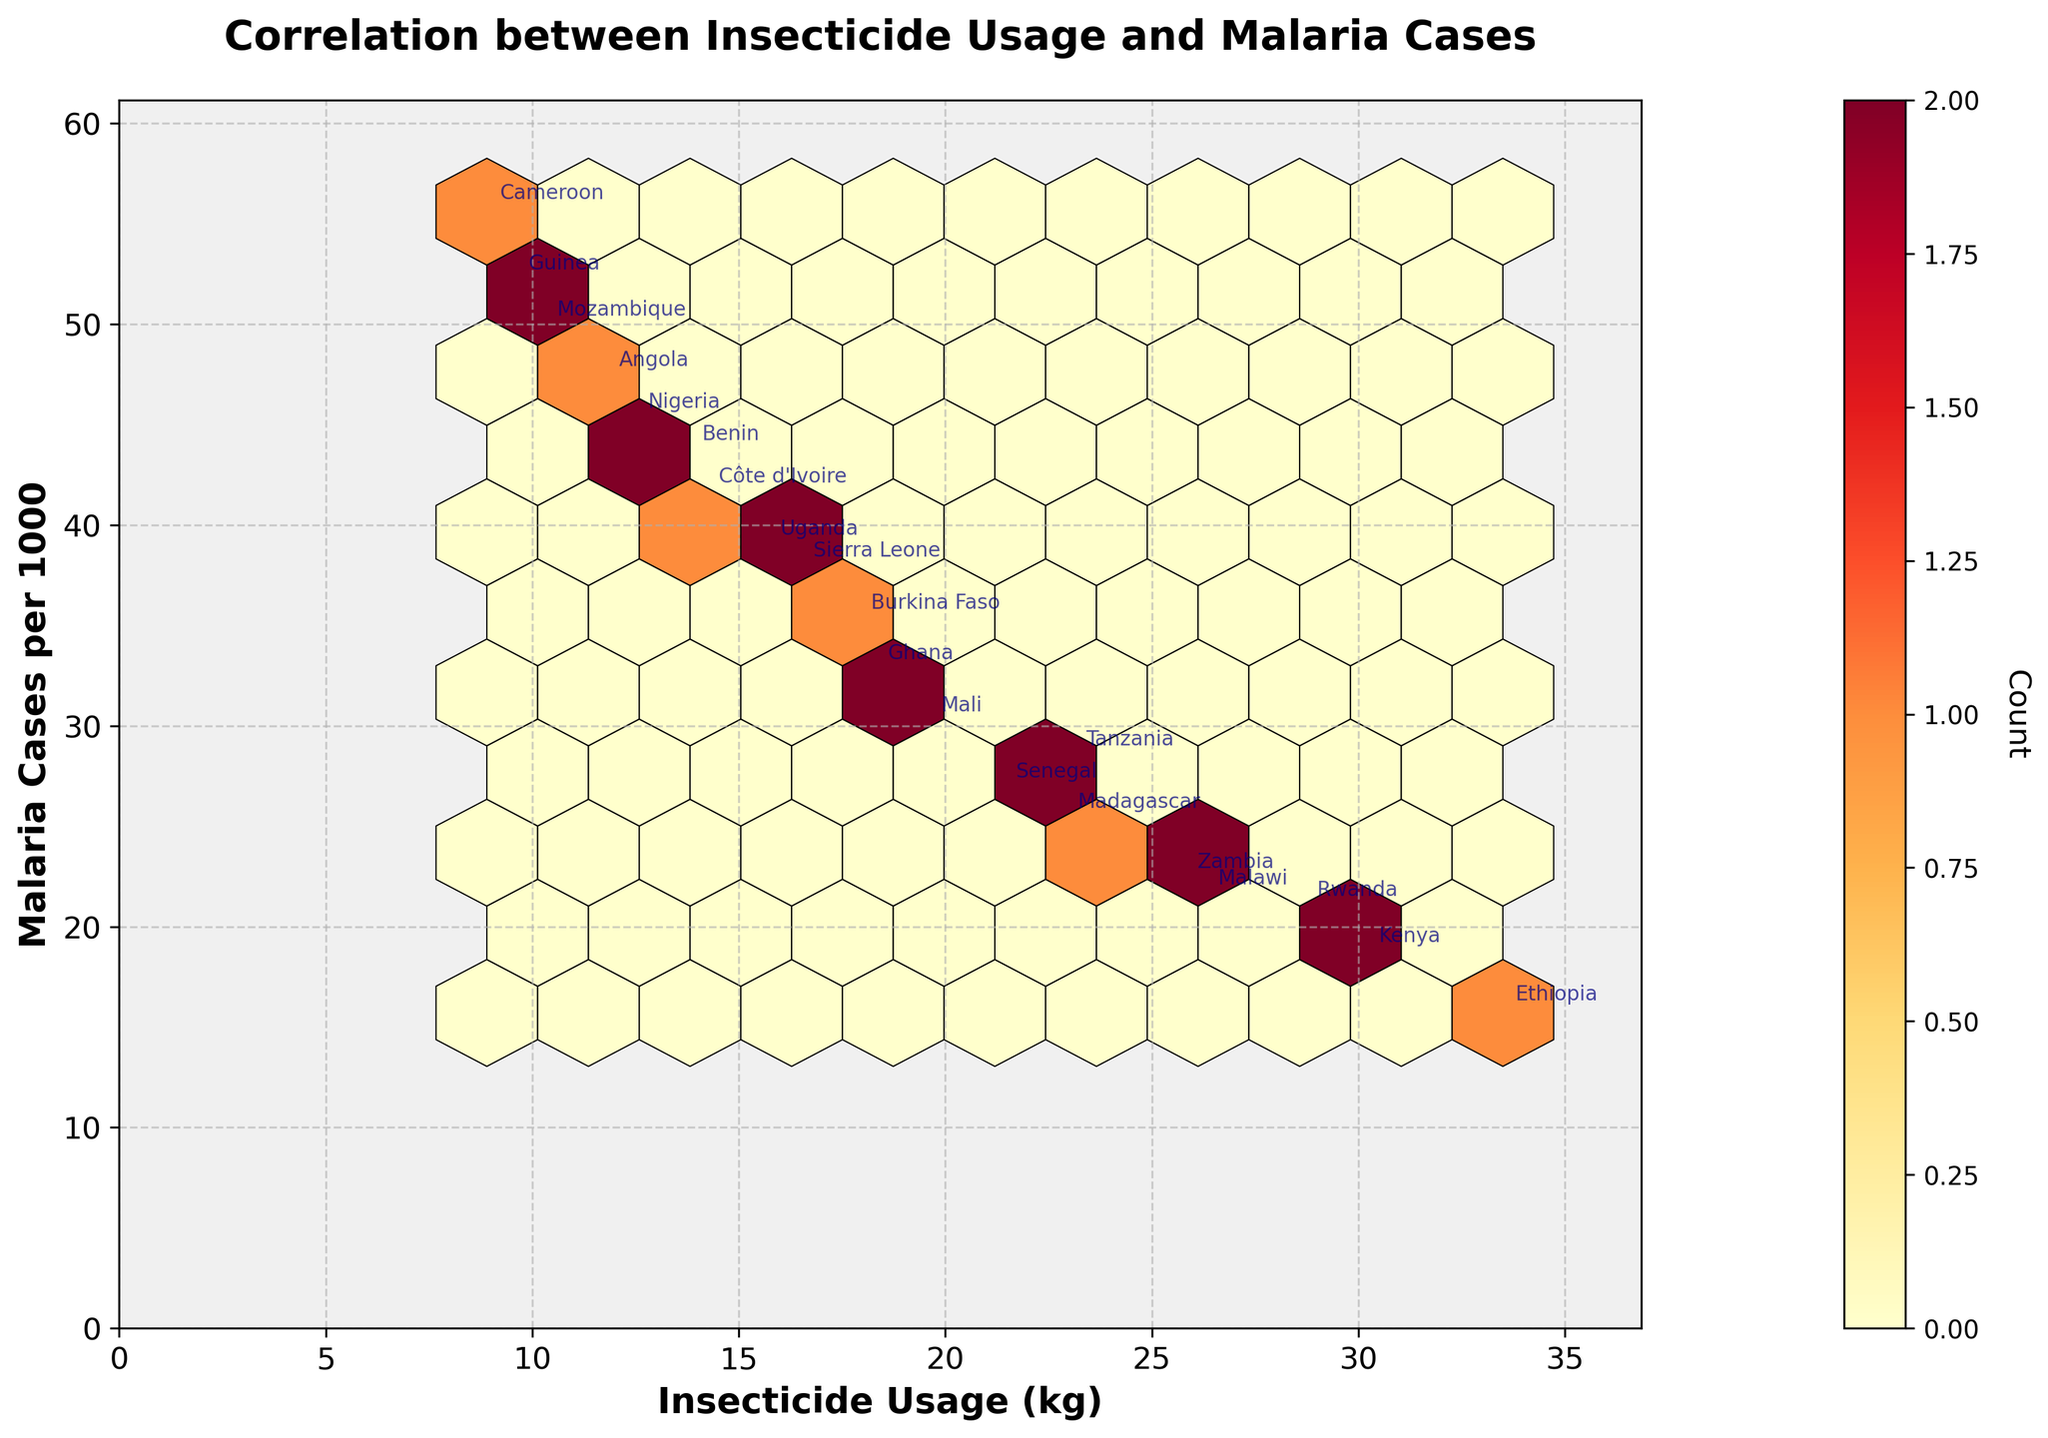what is the title of the plot? The title of the plot is prominently displayed at the top and serves to provide context for the visualization. It generally summarizes the main insight or relationship being explored in the graph.
Answer: Correlation between Insecticide Usage and Malaria Cases What are the x and y axis labels? The x-axis label is situated at the bottom of the x-axis, and the y-axis label is perpendicular to the y-axis. These labels provide information about what each axis represents.
Answer: Insecticide Usage (kg) and Malaria Cases per 1000 What does the color gradient represent? The color gradient in a hexbin plot usually indicates the density of the data points within each hexbin. Warmer colors typically represent higher density and cooler colors represent lower density.
Answer: Density of data points Which country has the lowest number of malaria cases per 1000? By observing the y-axis and checking the annotated points, we can locate which point is at the lowest position. This point corresponds to the country with the least malaria cases.
Answer: Ethiopia What is the insecticide usage range for most countries? To answer this, observe where the majority of hexbin points are concentrated along the x-axis. This range represents the insecticide usage for most countries.
Answer: Between 10 kg and 30 kg How many countries have malaria cases per 1000 above 50? Find and count the annotations that are located above the y-axis value of 50 to obtain the number of countries falling in this category.
Answer: 2 countries (Cameroon and Guinea) Is there a visible correlation between insecticide usage and malaria cases? Examine the general trend of hexbin clusters from left (low insecticide usage) to right (high insecticide usage). A downward trend would suggest that higher insecticide usage is associated with lower malaria cases.
Answer: Yes, there appears to be a negative correlation Which country shows a surprisingly high insecticide usage but still has relatively high malaria cases? Look for any points that deviate from the general downward trend, specifically those on the right side (high insecticide usage) but high on the y-axis (high malaria cases).
Answer: Mozambique What does each hexagonal bin represent? Each hexagonal bin on the plot represents a certain range of insecticide usage and malaria cases per 1000. The color of the hexbin indicates the number of countries that fall within that specific range.
Answer: Range of insecticide usage and malaria cases Which country has a malaria case rate closest to the median value among all listed countries? To find the median, list all malaria case rates in ascending order and find the middle value. Then, identify the country associated with this value by checking the annotations in the hexbin plot.
Answer: Sierra Leone 